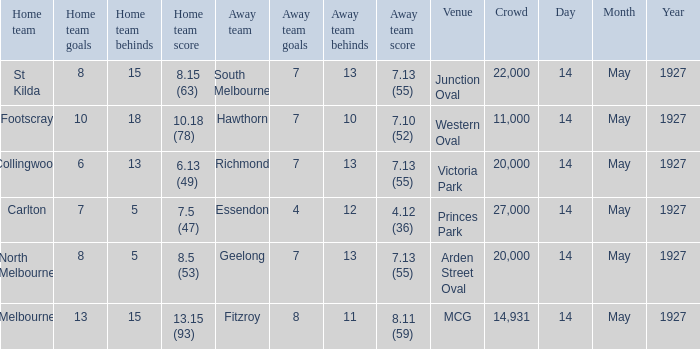Which away team had a score of 4.12 (36)? Essendon. 